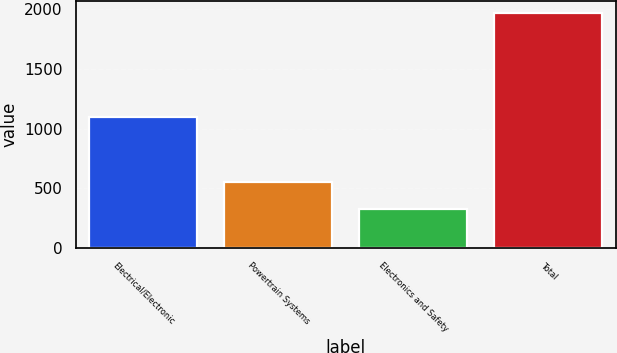<chart> <loc_0><loc_0><loc_500><loc_500><bar_chart><fcel>Electrical/Electronic<fcel>Powertrain Systems<fcel>Electronics and Safety<fcel>Total<nl><fcel>1095<fcel>553<fcel>323<fcel>1971<nl></chart> 